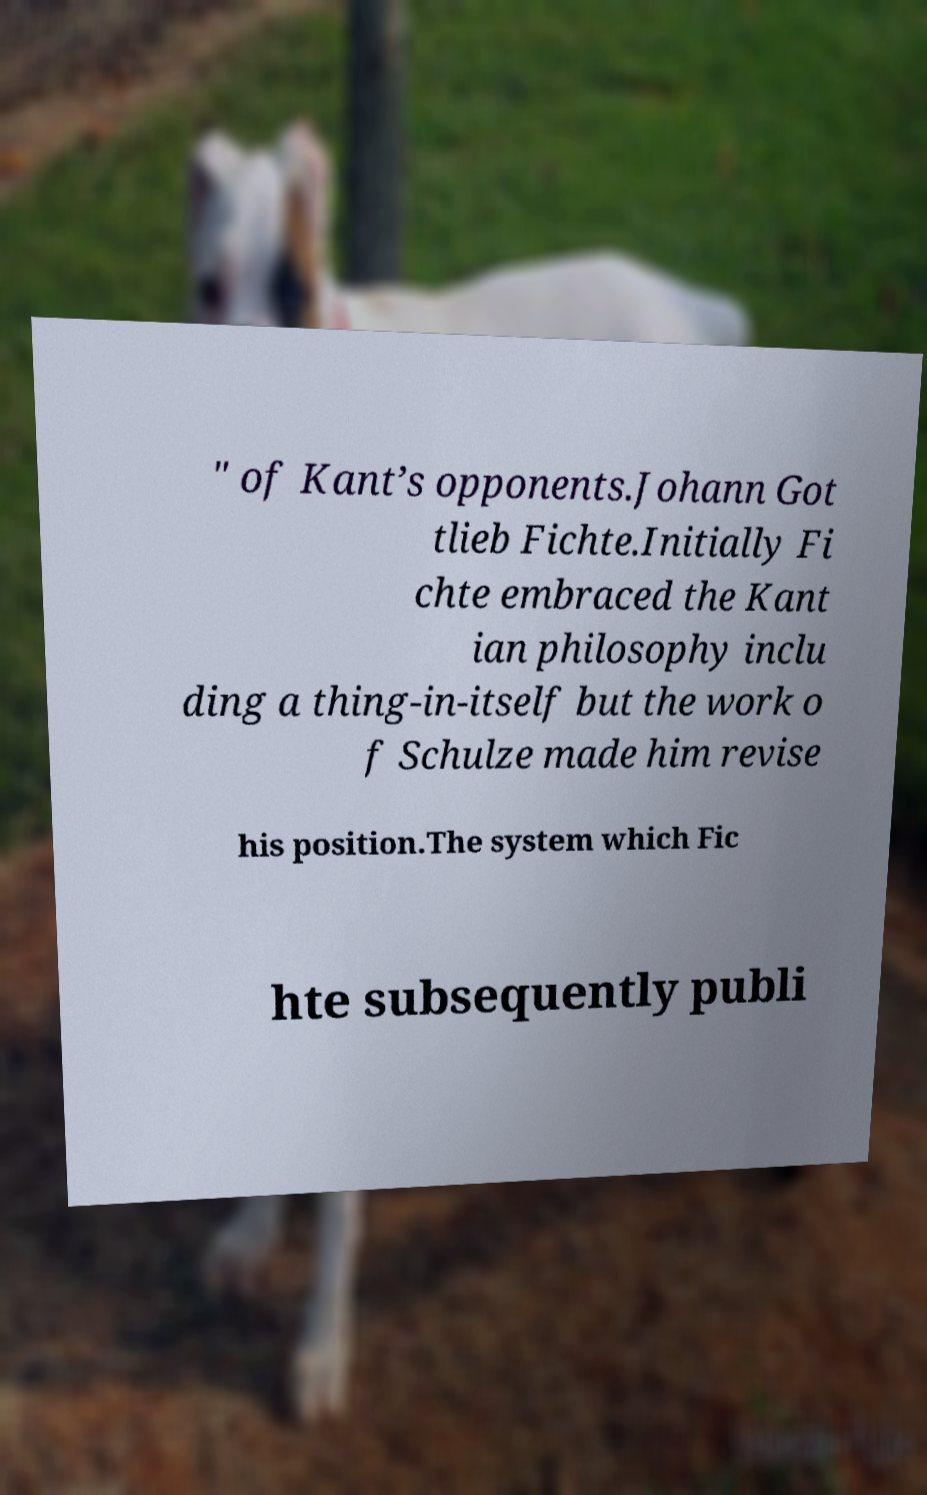Please identify and transcribe the text found in this image. " of Kant’s opponents.Johann Got tlieb Fichte.Initially Fi chte embraced the Kant ian philosophy inclu ding a thing-in-itself but the work o f Schulze made him revise his position.The system which Fic hte subsequently publi 